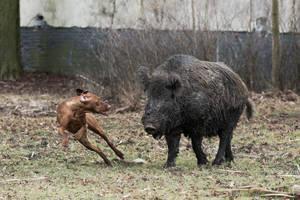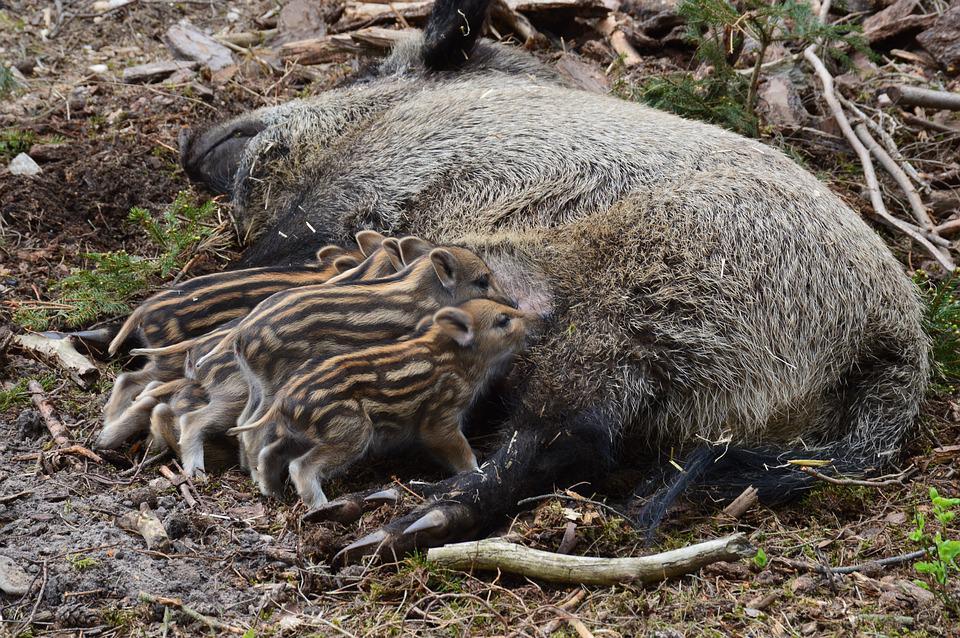The first image is the image on the left, the second image is the image on the right. For the images displayed, is the sentence "In one of the images there is a man posing behind a large boar." factually correct? Answer yes or no. No. The first image is the image on the left, the second image is the image on the right. For the images shown, is this caption "An image shows a person posed behind a dead boar." true? Answer yes or no. No. 